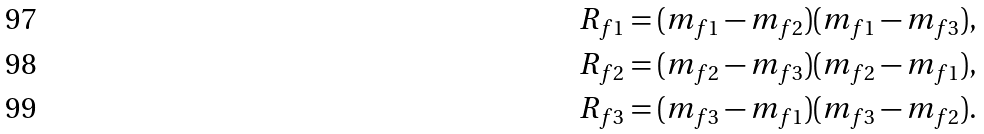Convert formula to latex. <formula><loc_0><loc_0><loc_500><loc_500>R _ { f 1 } & = ( m _ { f 1 } - m _ { f 2 } ) ( m _ { f 1 } - m _ { f 3 } ) , \\ R _ { f 2 } & = ( m _ { f 2 } - m _ { f 3 } ) ( m _ { f 2 } - m _ { f 1 } ) , \\ R _ { f 3 } & = ( m _ { f 3 } - m _ { f 1 } ) ( m _ { f 3 } - m _ { f 2 } ) .</formula> 